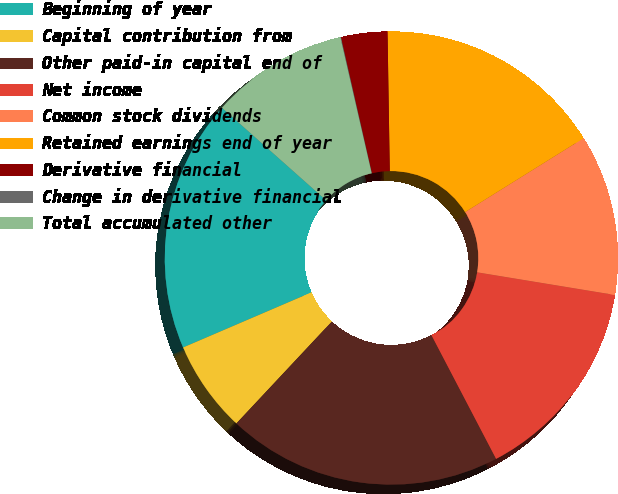<chart> <loc_0><loc_0><loc_500><loc_500><pie_chart><fcel>Beginning of year<fcel>Capital contribution from<fcel>Other paid-in capital end of<fcel>Net income<fcel>Common stock dividends<fcel>Retained earnings end of year<fcel>Derivative financial<fcel>Change in derivative financial<fcel>Total accumulated other<nl><fcel>18.01%<fcel>6.57%<fcel>19.64%<fcel>14.74%<fcel>11.47%<fcel>16.38%<fcel>3.3%<fcel>0.04%<fcel>9.84%<nl></chart> 